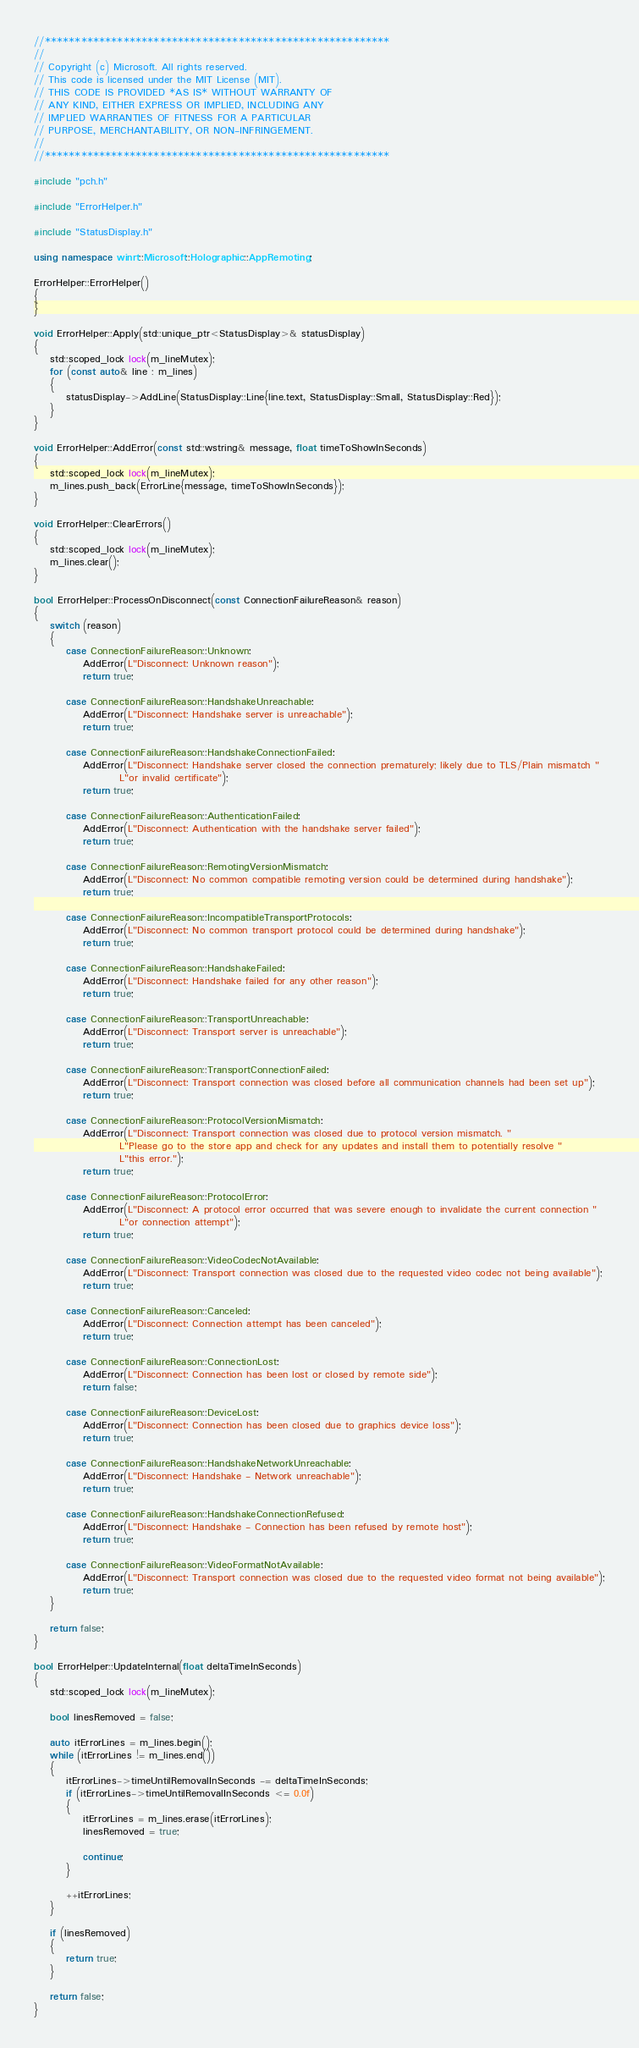<code> <loc_0><loc_0><loc_500><loc_500><_C++_>//*********************************************************
//
// Copyright (c) Microsoft. All rights reserved.
// This code is licensed under the MIT License (MIT).
// THIS CODE IS PROVIDED *AS IS* WITHOUT WARRANTY OF
// ANY KIND, EITHER EXPRESS OR IMPLIED, INCLUDING ANY
// IMPLIED WARRANTIES OF FITNESS FOR A PARTICULAR
// PURPOSE, MERCHANTABILITY, OR NON-INFRINGEMENT.
//
//*********************************************************

#include "pch.h"

#include "ErrorHelper.h"

#include "StatusDisplay.h"

using namespace winrt::Microsoft::Holographic::AppRemoting;

ErrorHelper::ErrorHelper()
{
}

void ErrorHelper::Apply(std::unique_ptr<StatusDisplay>& statusDisplay)
{
    std::scoped_lock lock(m_lineMutex);
    for (const auto& line : m_lines)
    {
        statusDisplay->AddLine(StatusDisplay::Line{line.text, StatusDisplay::Small, StatusDisplay::Red});
    }
}

void ErrorHelper::AddError(const std::wstring& message, float timeToShowInSeconds)
{
    std::scoped_lock lock(m_lineMutex);
    m_lines.push_back(ErrorLine{message, timeToShowInSeconds});
}

void ErrorHelper::ClearErrors()
{
    std::scoped_lock lock(m_lineMutex);
    m_lines.clear();
}

bool ErrorHelper::ProcessOnDisconnect(const ConnectionFailureReason& reason)
{
    switch (reason)
    {
        case ConnectionFailureReason::Unknown:
            AddError(L"Disconnect: Unknown reason");
            return true;

        case ConnectionFailureReason::HandshakeUnreachable:
            AddError(L"Disconnect: Handshake server is unreachable");
            return true;

        case ConnectionFailureReason::HandshakeConnectionFailed:
            AddError(L"Disconnect: Handshake server closed the connection prematurely; likely due to TLS/Plain mismatch "
                     L"or invalid certificate");
            return true;

        case ConnectionFailureReason::AuthenticationFailed:
            AddError(L"Disconnect: Authentication with the handshake server failed");
            return true;

        case ConnectionFailureReason::RemotingVersionMismatch:
            AddError(L"Disconnect: No common compatible remoting version could be determined during handshake");
            return true;

        case ConnectionFailureReason::IncompatibleTransportProtocols:
            AddError(L"Disconnect: No common transport protocol could be determined during handshake");
            return true;

        case ConnectionFailureReason::HandshakeFailed:
            AddError(L"Disconnect: Handshake failed for any other reason");
            return true;

        case ConnectionFailureReason::TransportUnreachable:
            AddError(L"Disconnect: Transport server is unreachable");
            return true;

        case ConnectionFailureReason::TransportConnectionFailed:
            AddError(L"Disconnect: Transport connection was closed before all communication channels had been set up");
            return true;

        case ConnectionFailureReason::ProtocolVersionMismatch:
            AddError(L"Disconnect: Transport connection was closed due to protocol version mismatch. "
                     L"Please go to the store app and check for any updates and install them to potentially resolve "
                     L"this error.");
            return true;

        case ConnectionFailureReason::ProtocolError:
            AddError(L"Disconnect: A protocol error occurred that was severe enough to invalidate the current connection "
                     L"or connection attempt");
            return true;

        case ConnectionFailureReason::VideoCodecNotAvailable:
            AddError(L"Disconnect: Transport connection was closed due to the requested video codec not being available");
            return true;

        case ConnectionFailureReason::Canceled:
            AddError(L"Disconnect: Connection attempt has been canceled");
            return true;

        case ConnectionFailureReason::ConnectionLost:
            AddError(L"Disconnect: Connection has been lost or closed by remote side");
            return false;

        case ConnectionFailureReason::DeviceLost:
            AddError(L"Disconnect: Connection has been closed due to graphics device loss");
            return true;

        case ConnectionFailureReason::HandshakeNetworkUnreachable:
            AddError(L"Disconnect: Handshake - Network unreachable");
            return true;

        case ConnectionFailureReason::HandshakeConnectionRefused:
            AddError(L"Disconnect: Handshake - Connection has been refused by remote host");
            return true;

        case ConnectionFailureReason::VideoFormatNotAvailable:
            AddError(L"Disconnect: Transport connection was closed due to the requested video format not being available");
            return true;
    }

    return false;
}

bool ErrorHelper::UpdateInternal(float deltaTimeInSeconds)
{
    std::scoped_lock lock(m_lineMutex);

    bool linesRemoved = false;

    auto itErrorLines = m_lines.begin();
    while (itErrorLines != m_lines.end())
    {
        itErrorLines->timeUntilRemovalInSeconds -= deltaTimeInSeconds;
        if (itErrorLines->timeUntilRemovalInSeconds <= 0.0f)
        {
            itErrorLines = m_lines.erase(itErrorLines);
            linesRemoved = true;

            continue;
        }

        ++itErrorLines;
    }

    if (linesRemoved)
    {
        return true;
    }

    return false;
}
</code> 